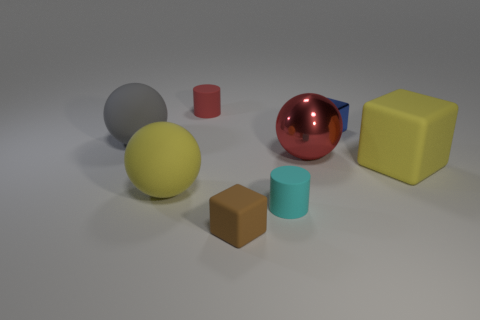Add 2 tiny blue objects. How many objects exist? 10 Subtract all spheres. How many objects are left? 5 Add 6 gray things. How many gray things exist? 7 Subtract 0 red blocks. How many objects are left? 8 Subtract all large blocks. Subtract all big rubber spheres. How many objects are left? 5 Add 3 tiny blue metallic cubes. How many tiny blue metallic cubes are left? 4 